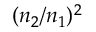Convert formula to latex. <formula><loc_0><loc_0><loc_500><loc_500>( n _ { 2 } / n _ { 1 } ) ^ { 2 }</formula> 